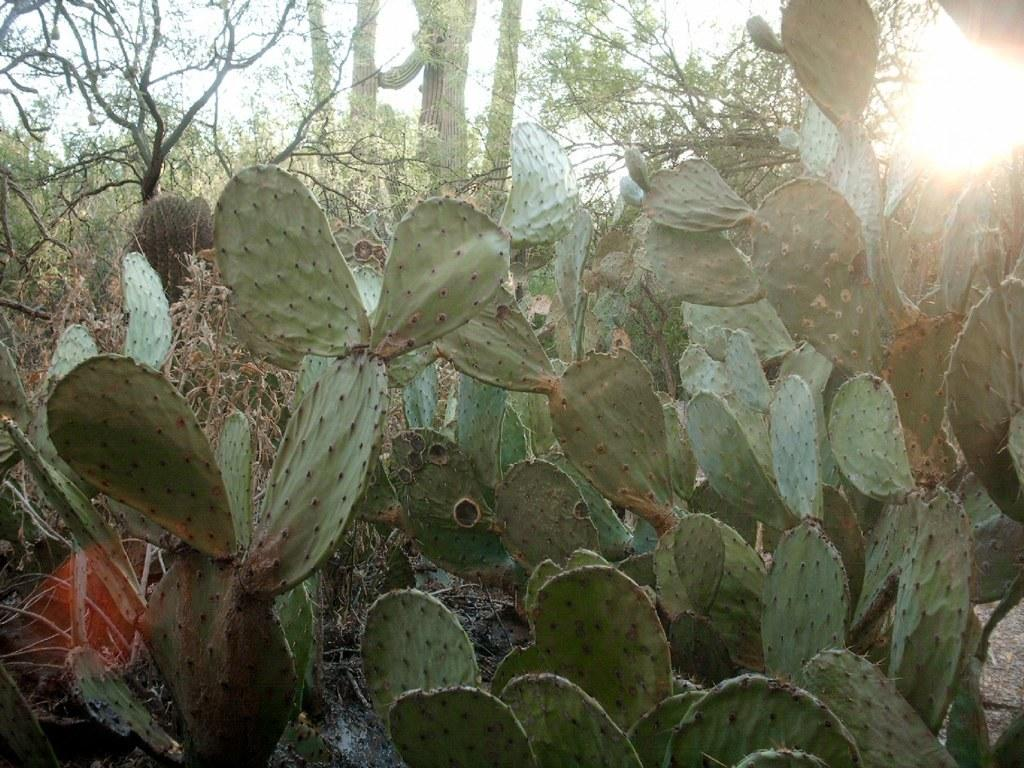What type of living organisms are in the image? There are plants in the image. What color are the plants in the image? The plants are green in color. What type of hate can be seen expressed by the plants in the image? There is no indication of hate or any emotions in the image, as plants do not have the ability to express emotions. What type of bubble can be seen surrounding the plants in the image? There is no bubble present in the image. 